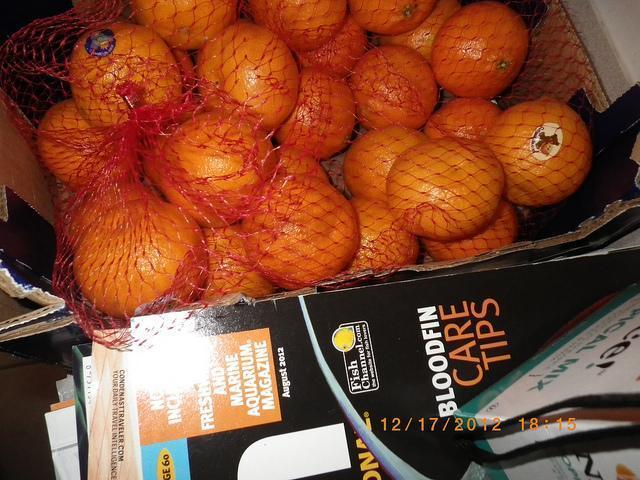How many oranges can you see?
Give a very brief answer. 14. How many books are in the photo?
Give a very brief answer. 2. 